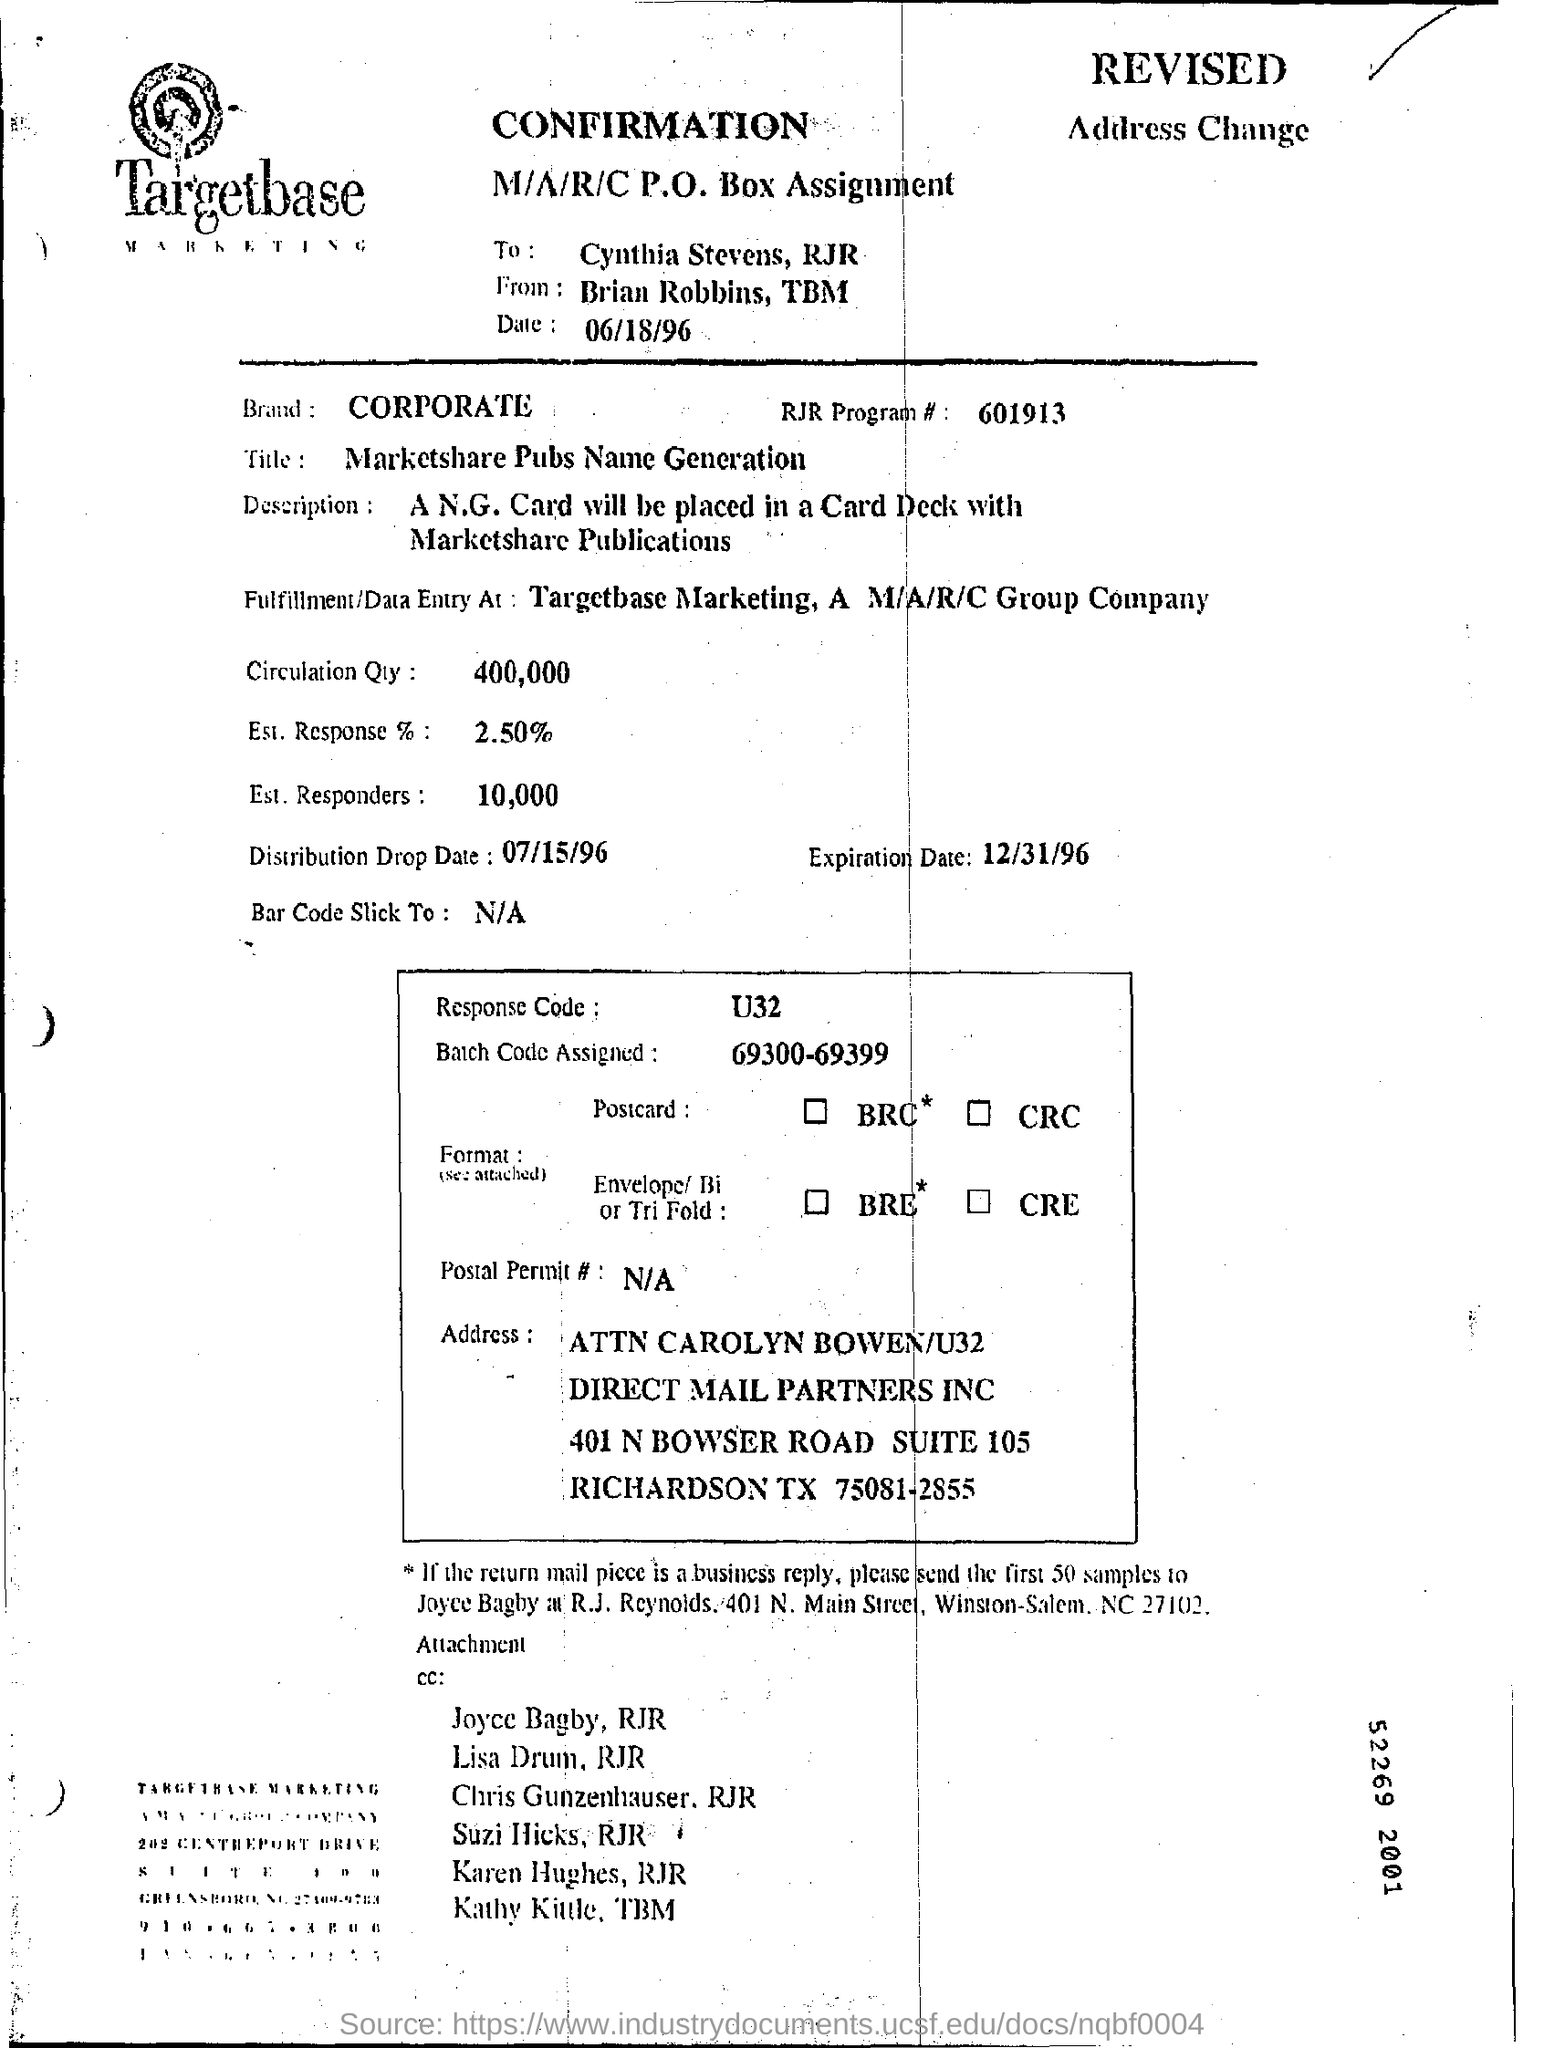Give some essential details in this illustration. The document is addressed to Cynthia Stevens of RJR. According to the document, an estimated 10,000 responders will be present. The letter is addressed to Targetbase Marketing, a company that is mentioned in the letterhead. The circulation quantity, as stated in the document, is 400,000. The expiration date mentioned in the document is December 31, 1996. 